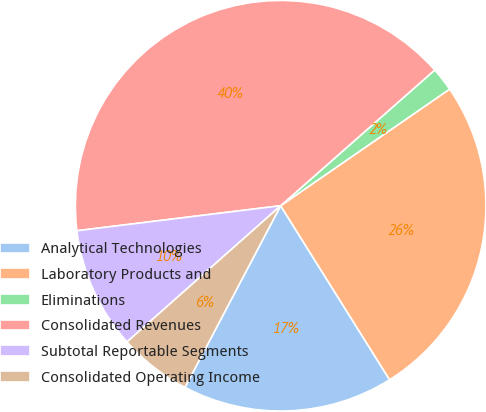Convert chart. <chart><loc_0><loc_0><loc_500><loc_500><pie_chart><fcel>Analytical Technologies<fcel>Laboratory Products and<fcel>Eliminations<fcel>Consolidated Revenues<fcel>Subtotal Reportable Segments<fcel>Consolidated Operating Income<nl><fcel>16.62%<fcel>25.71%<fcel>1.88%<fcel>40.45%<fcel>9.6%<fcel>5.74%<nl></chart> 